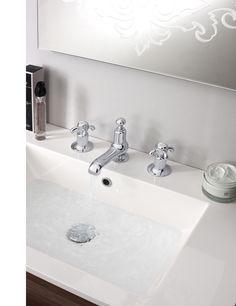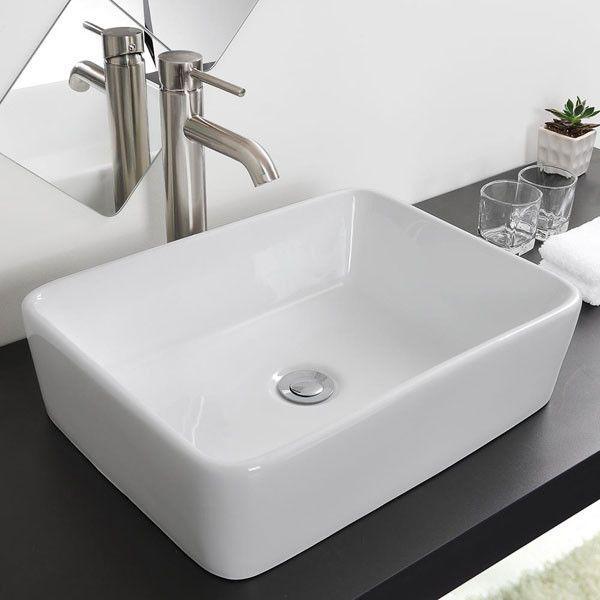The first image is the image on the left, the second image is the image on the right. Examine the images to the left and right. Is the description "The combined images include two wall-mounted sinks with metal pipes exposed underneath them, and at least one sink has faucets integrated with the spout." accurate? Answer yes or no. No. The first image is the image on the left, the second image is the image on the right. Given the left and right images, does the statement "Exactly two bathroom sinks are shown, one with hot and cold water faucets, while the other has a single unright faucet." hold true? Answer yes or no. Yes. 